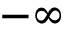<formula> <loc_0><loc_0><loc_500><loc_500>- \infty</formula> 